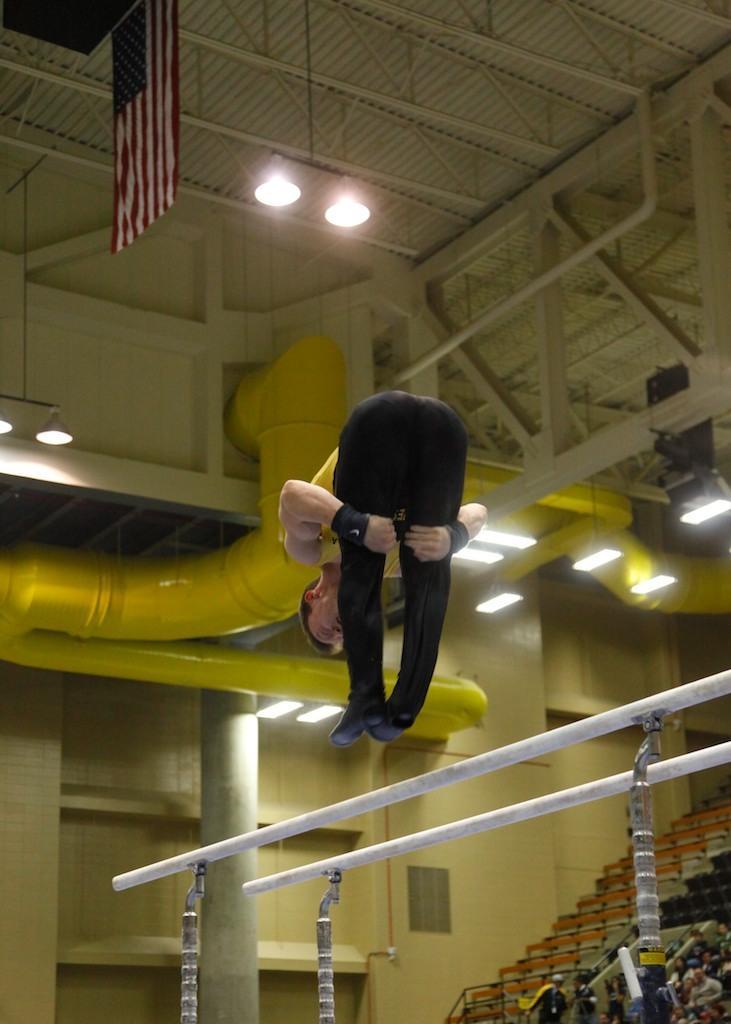How would you summarize this image in a sentence or two? In this picture we can see a person is in the air, poles, some people, flag, roof, lights, pipes, wall, pillar and some objects. 